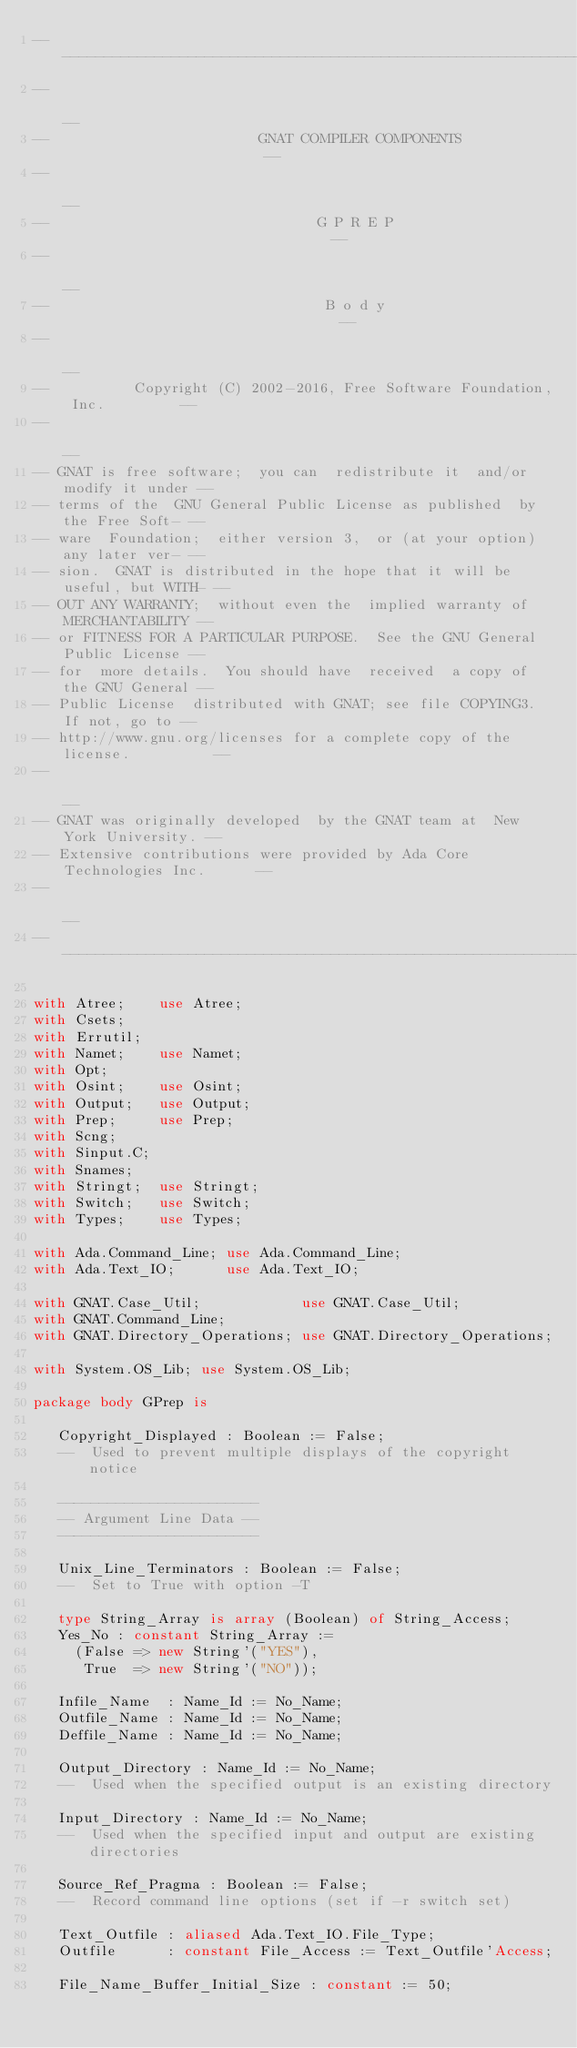<code> <loc_0><loc_0><loc_500><loc_500><_Ada_>------------------------------------------------------------------------------
--                                                                          --
--                         GNAT COMPILER COMPONENTS                         --
--                                                                          --
--                                G P R E P                                 --
--                                                                          --
--                                 B o d y                                  --
--                                                                          --
--          Copyright (C) 2002-2016, Free Software Foundation, Inc.         --
--                                                                          --
-- GNAT is free software;  you can  redistribute it  and/or modify it under --
-- terms of the  GNU General Public License as published  by the Free Soft- --
-- ware  Foundation;  either version 3,  or (at your option) any later ver- --
-- sion.  GNAT is distributed in the hope that it will be useful, but WITH- --
-- OUT ANY WARRANTY;  without even the  implied warranty of MERCHANTABILITY --
-- or FITNESS FOR A PARTICULAR PURPOSE.  See the GNU General Public License --
-- for  more details.  You should have  received  a copy of the GNU General --
-- Public License  distributed with GNAT; see file COPYING3.  If not, go to --
-- http://www.gnu.org/licenses for a complete copy of the license.          --
--                                                                          --
-- GNAT was originally developed  by the GNAT team at  New York University. --
-- Extensive contributions were provided by Ada Core Technologies Inc.      --
--                                                                          --
------------------------------------------------------------------------------

with Atree;    use Atree;
with Csets;
with Errutil;
with Namet;    use Namet;
with Opt;
with Osint;    use Osint;
with Output;   use Output;
with Prep;     use Prep;
with Scng;
with Sinput.C;
with Snames;
with Stringt;  use Stringt;
with Switch;   use Switch;
with Types;    use Types;

with Ada.Command_Line; use Ada.Command_Line;
with Ada.Text_IO;      use Ada.Text_IO;

with GNAT.Case_Util;            use GNAT.Case_Util;
with GNAT.Command_Line;
with GNAT.Directory_Operations; use GNAT.Directory_Operations;

with System.OS_Lib; use System.OS_Lib;

package body GPrep is

   Copyright_Displayed : Boolean := False;
   --  Used to prevent multiple displays of the copyright notice

   ------------------------
   -- Argument Line Data --
   ------------------------

   Unix_Line_Terminators : Boolean := False;
   --  Set to True with option -T

   type String_Array is array (Boolean) of String_Access;
   Yes_No : constant String_Array :=
     (False => new String'("YES"),
      True  => new String'("NO"));

   Infile_Name  : Name_Id := No_Name;
   Outfile_Name : Name_Id := No_Name;
   Deffile_Name : Name_Id := No_Name;

   Output_Directory : Name_Id := No_Name;
   --  Used when the specified output is an existing directory

   Input_Directory : Name_Id := No_Name;
   --  Used when the specified input and output are existing directories

   Source_Ref_Pragma : Boolean := False;
   --  Record command line options (set if -r switch set)

   Text_Outfile : aliased Ada.Text_IO.File_Type;
   Outfile      : constant File_Access := Text_Outfile'Access;

   File_Name_Buffer_Initial_Size : constant := 50;</code> 